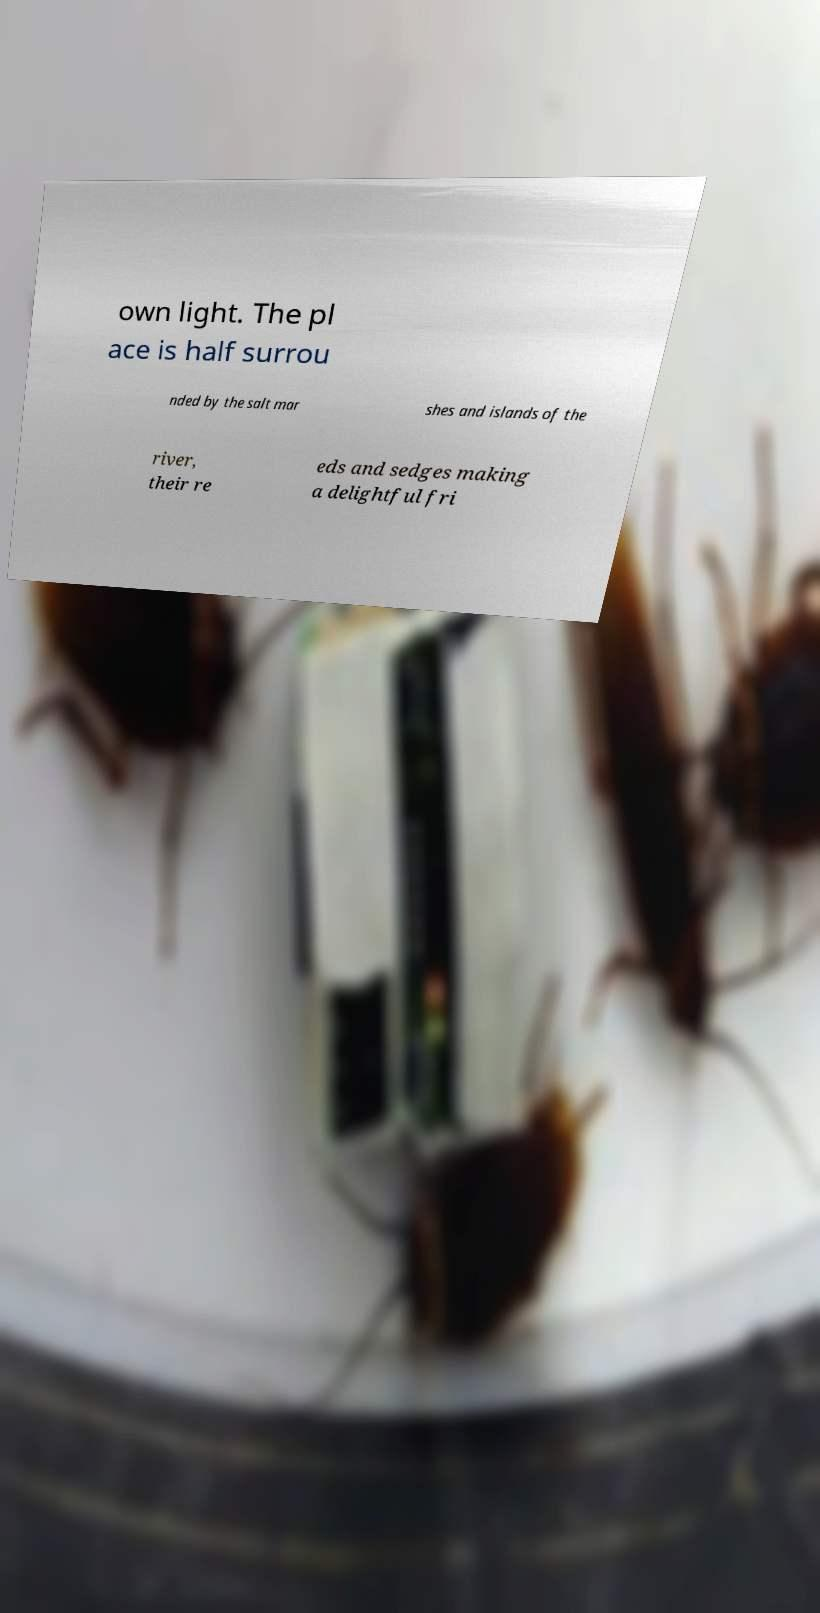Can you read and provide the text displayed in the image?This photo seems to have some interesting text. Can you extract and type it out for me? own light. The pl ace is half surrou nded by the salt mar shes and islands of the river, their re eds and sedges making a delightful fri 